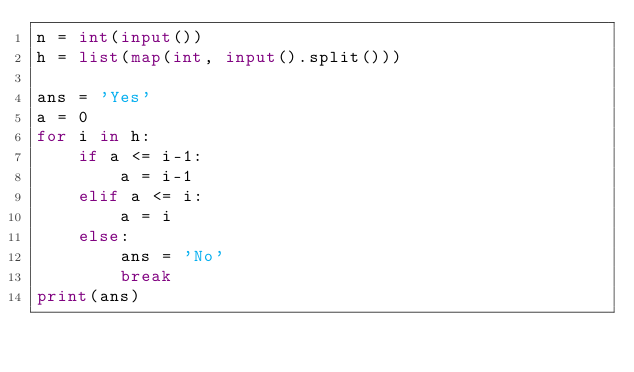<code> <loc_0><loc_0><loc_500><loc_500><_Python_>n = int(input())
h = list(map(int, input().split()))

ans = 'Yes'
a = 0
for i in h:
    if a <= i-1:
        a = i-1
    elif a <= i:
        a = i
    else:
        ans = 'No'
        break
print(ans)</code> 